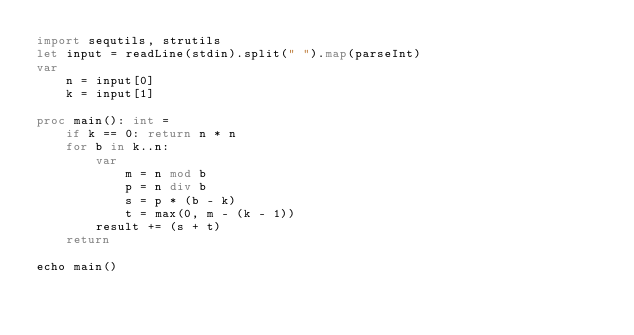Convert code to text. <code><loc_0><loc_0><loc_500><loc_500><_Nim_>import sequtils, strutils
let input = readLine(stdin).split(" ").map(parseInt)
var
    n = input[0]
    k = input[1]
 
proc main(): int =
    if k == 0: return n * n
    for b in k..n:
        var
            m = n mod b
            p = n div b
            s = p * (b - k)
            t = max(0, m - (k - 1))
        result += (s + t)
    return
 
echo main()</code> 